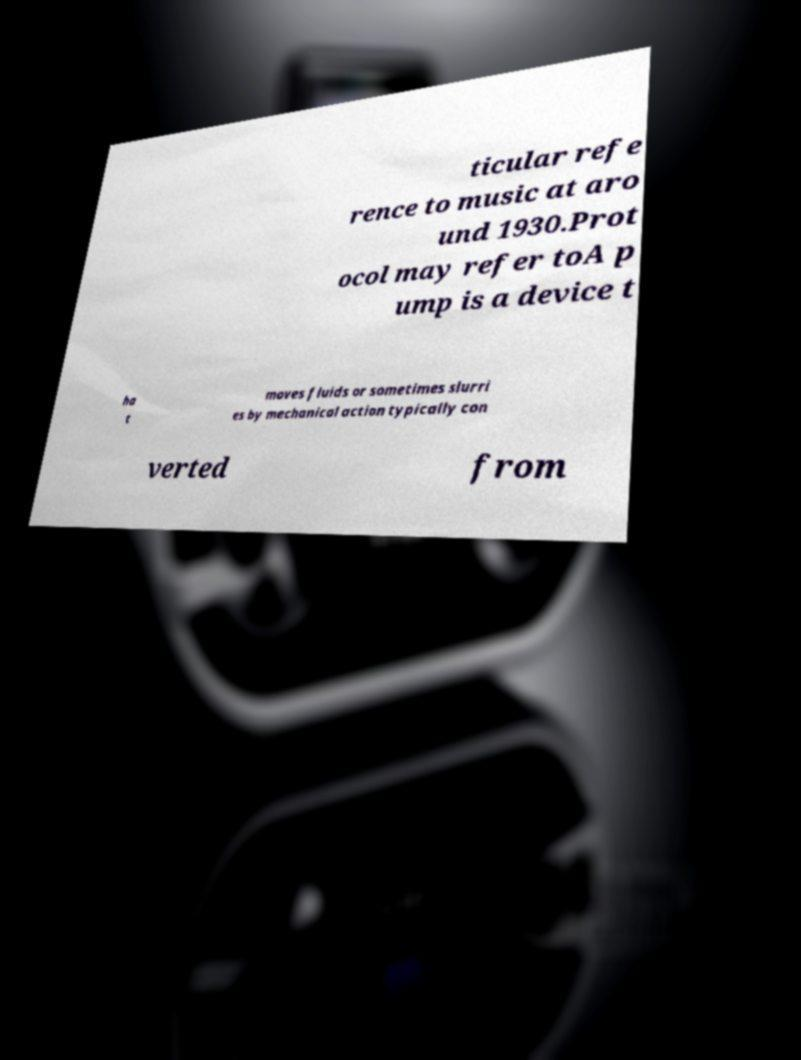I need the written content from this picture converted into text. Can you do that? ticular refe rence to music at aro und 1930.Prot ocol may refer toA p ump is a device t ha t moves fluids or sometimes slurri es by mechanical action typically con verted from 